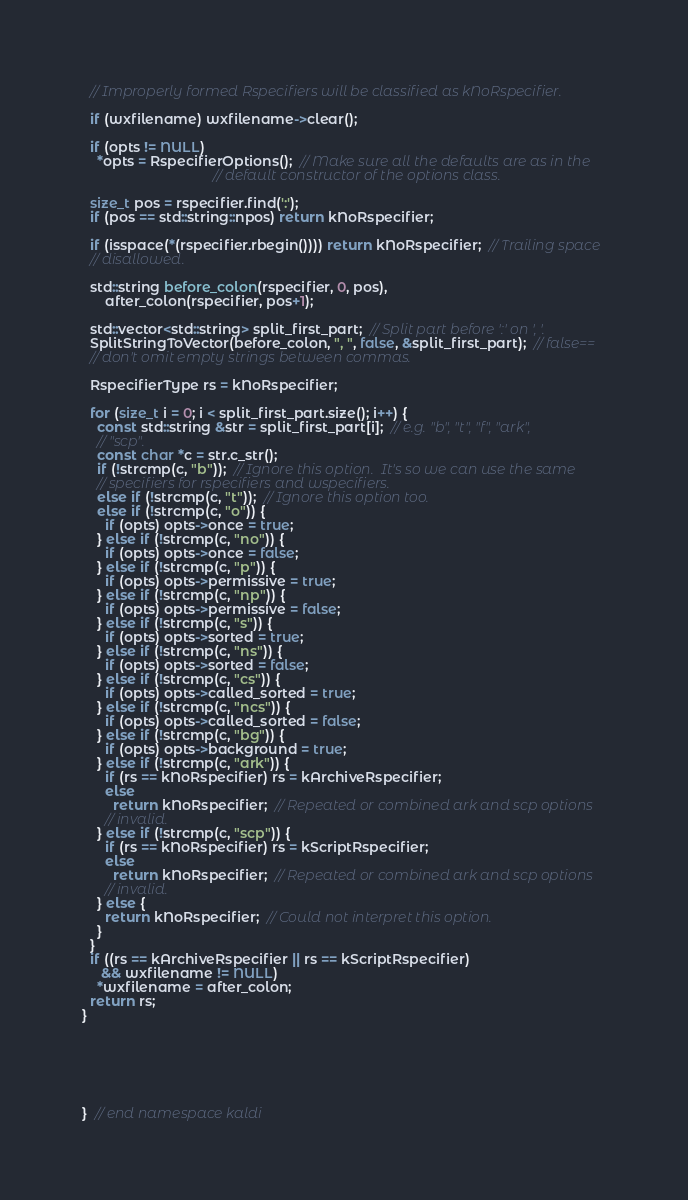Convert code to text. <code><loc_0><loc_0><loc_500><loc_500><_C++_>  // Improperly formed Rspecifiers will be classified as kNoRspecifier.

  if (wxfilename) wxfilename->clear();

  if (opts != NULL)
    *opts = RspecifierOptions();  // Make sure all the defaults are as in the
                                  // default constructor of the options class.

  size_t pos = rspecifier.find(':');
  if (pos == std::string::npos) return kNoRspecifier;

  if (isspace(*(rspecifier.rbegin()))) return kNoRspecifier;  // Trailing space
  // disallowed.

  std::string before_colon(rspecifier, 0, pos),
      after_colon(rspecifier, pos+1);

  std::vector<std::string> split_first_part;  // Split part before ':' on ', '.
  SplitStringToVector(before_colon, ", ", false, &split_first_part);  // false==
  // don't omit empty strings between commas.

  RspecifierType rs = kNoRspecifier;

  for (size_t i = 0; i < split_first_part.size(); i++) {
    const std::string &str = split_first_part[i];  // e.g. "b", "t", "f", "ark",
    // "scp".
    const char *c = str.c_str();
    if (!strcmp(c, "b"));  // Ignore this option.  It's so we can use the same
    // specifiers for rspecifiers and wspecifiers.
    else if (!strcmp(c, "t"));  // Ignore this option too.
    else if (!strcmp(c, "o")) {
      if (opts) opts->once = true;
    } else if (!strcmp(c, "no")) {
      if (opts) opts->once = false;
    } else if (!strcmp(c, "p")) {
      if (opts) opts->permissive = true;
    } else if (!strcmp(c, "np")) {
      if (opts) opts->permissive = false;
    } else if (!strcmp(c, "s")) {
      if (opts) opts->sorted = true;
    } else if (!strcmp(c, "ns")) {
      if (opts) opts->sorted = false;
    } else if (!strcmp(c, "cs")) {
      if (opts) opts->called_sorted = true;
    } else if (!strcmp(c, "ncs")) {
      if (opts) opts->called_sorted = false;
    } else if (!strcmp(c, "bg")) {
      if (opts) opts->background = true;
    } else if (!strcmp(c, "ark")) {
      if (rs == kNoRspecifier) rs = kArchiveRspecifier;
      else
        return kNoRspecifier;  // Repeated or combined ark and scp options
      // invalid.
    } else if (!strcmp(c, "scp")) {
      if (rs == kNoRspecifier) rs = kScriptRspecifier;
      else
        return kNoRspecifier;  // Repeated or combined ark and scp options
      // invalid.
    } else {
      return kNoRspecifier;  // Could not interpret this option.
    }
  }
  if ((rs == kArchiveRspecifier || rs == kScriptRspecifier)
     && wxfilename != NULL)
    *wxfilename = after_colon;
  return rs;
}






}  // end namespace kaldi
</code> 